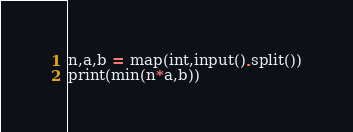Convert code to text. <code><loc_0><loc_0><loc_500><loc_500><_Python_>n,a,b = map(int,input().split())
print(min(n*a,b))</code> 